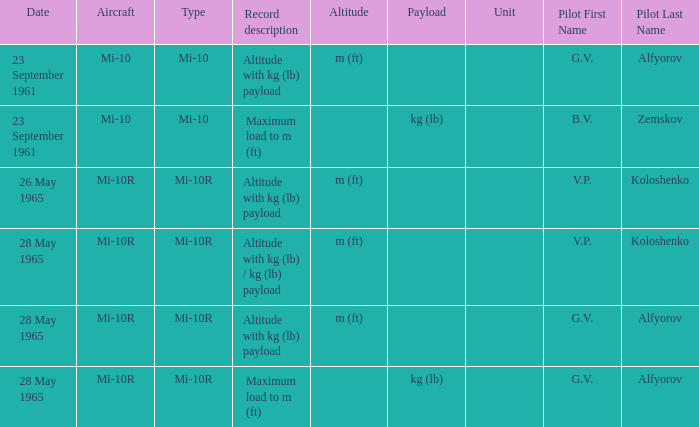Record description of maximum load to m (ft), and a Date of 23 september 1961 is what pilot? B.V. Zemskov. 